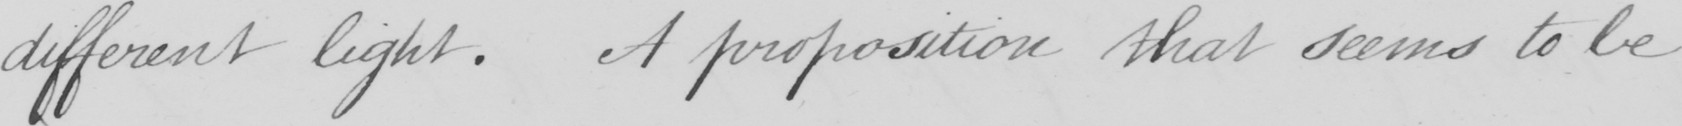Can you read and transcribe this handwriting? different light . A proposition that seems to be 